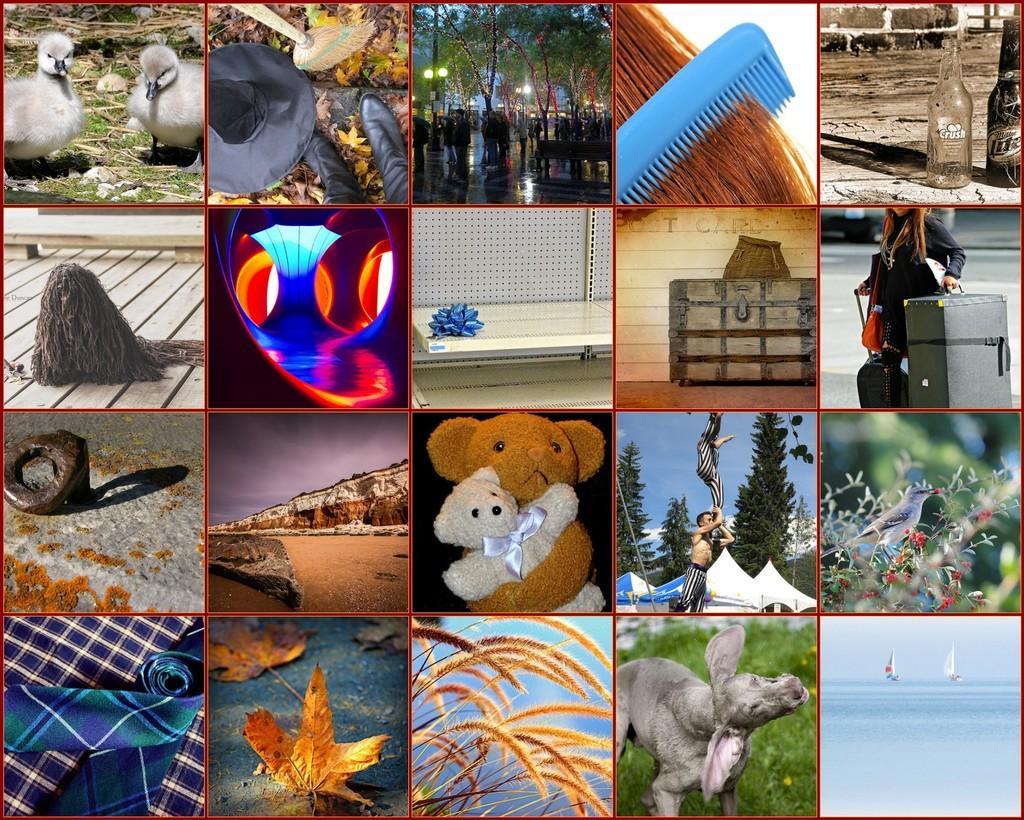Please provide a concise description of this image. As we can see in the image there is college of white color ducks, comb, group of people, bottles, a woman holding suitcase, teddy bears, trees, plants, an animal, dry leaves and a cloth. 